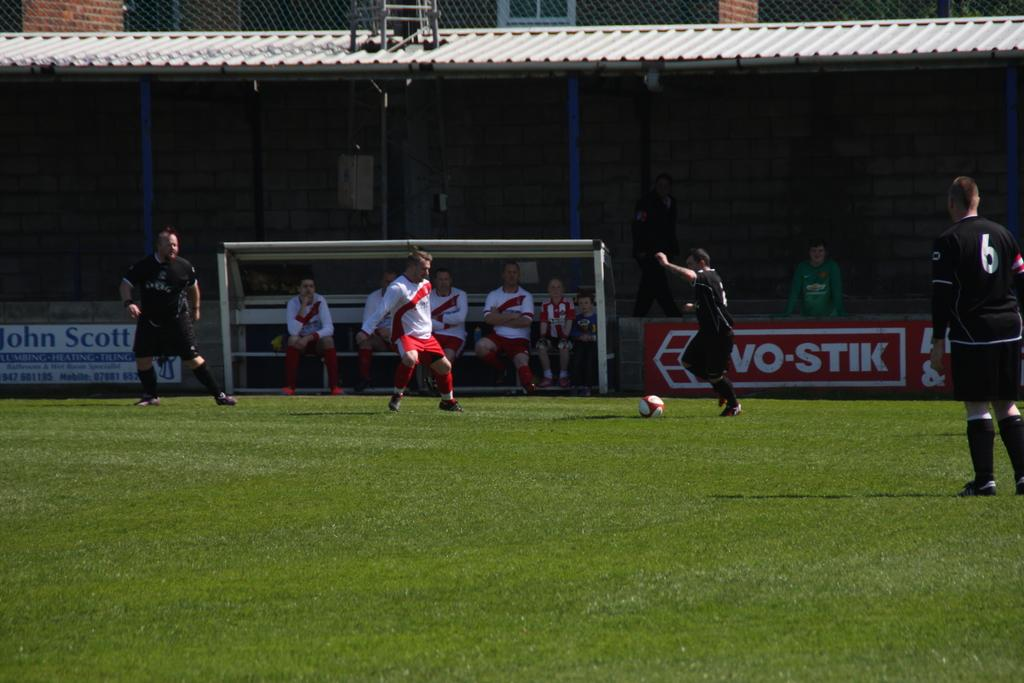<image>
Present a compact description of the photo's key features. The white and blue sign behind the goal has the name John Scott 